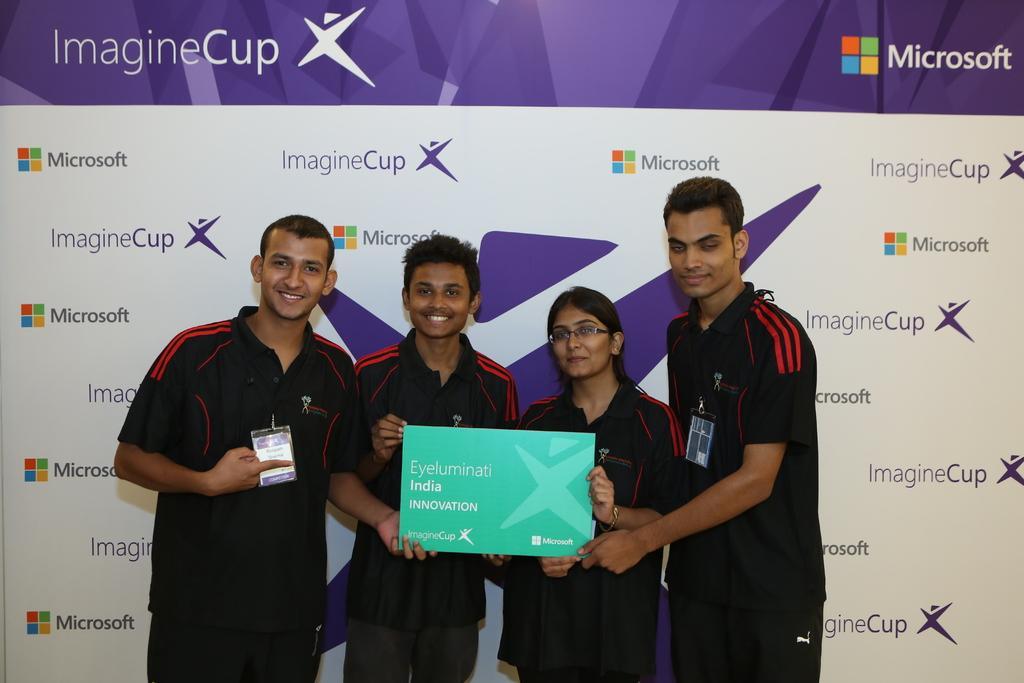In one or two sentences, can you explain what this image depicts? In this picture we can observe four members. Three of them are men and the other is a woman. They are holding green color card. We can observe some text on this card. In the background we can observe a poster which is in violet and white color. 